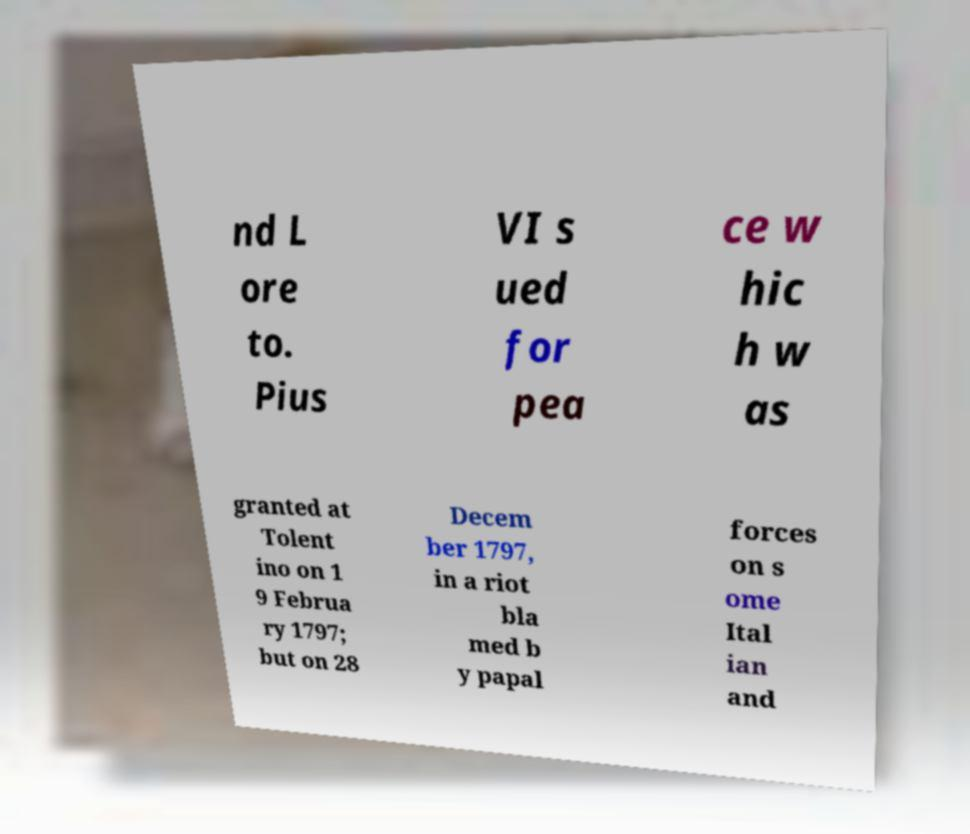Can you accurately transcribe the text from the provided image for me? nd L ore to. Pius VI s ued for pea ce w hic h w as granted at Tolent ino on 1 9 Februa ry 1797; but on 28 Decem ber 1797, in a riot bla med b y papal forces on s ome Ital ian and 